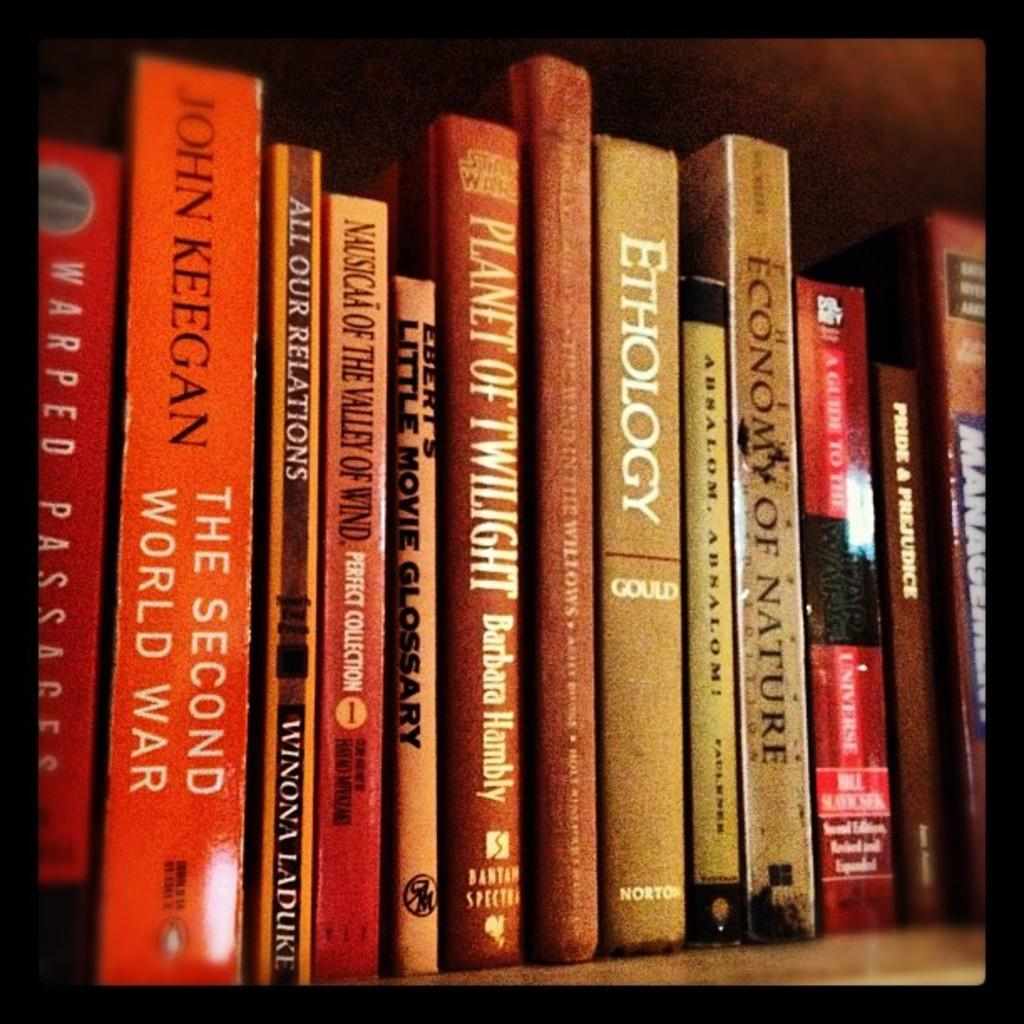<image>
Provide a brief description of the given image. A collection of books with everything from The Second World War to Ethology by Gould. 